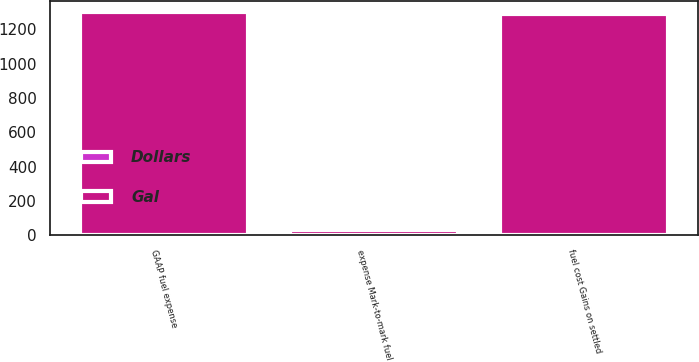<chart> <loc_0><loc_0><loc_500><loc_500><stacked_bar_chart><ecel><fcel>fuel cost Gains on settled<fcel>expense Mark-to-mark fuel<fcel>GAAP fuel expense<nl><fcel>Gal<fcel>1289<fcel>30<fcel>1298<nl><fcel>Dollars<fcel>3.24<fcel>0.08<fcel>3.26<nl></chart> 